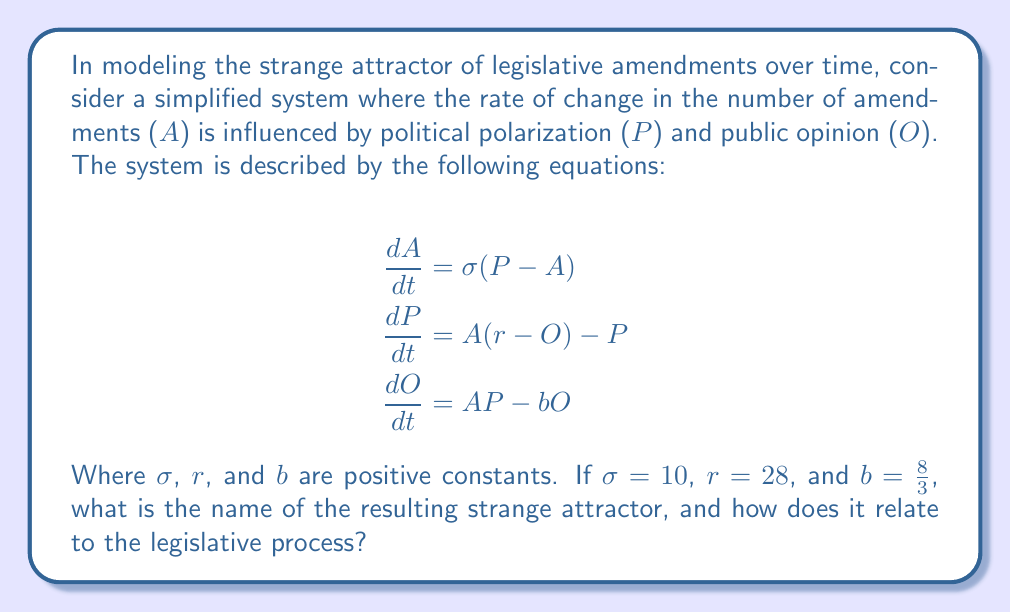Could you help me with this problem? To solve this problem, we need to follow these steps:

1) Recognize the system of equations:
   The given system is a modified version of the Lorenz equations, which are famous for producing chaotic behavior and strange attractors.

2) Identify the variables:
   $A$ represents the number of amendments
   $P$ represents political polarization
   $O$ represents public opinion

3) Analyze the parameters:
   $\sigma = 10$
   $r = 28$
   $b = \frac{8}{3}$

   These are the classic parameters that produce the Lorenz attractor.

4) Understand the Lorenz attractor:
   The Lorenz attractor is a set of chaotic solutions of the Lorenz system which, when plotted, resemble a butterfly or figure-eight pattern.

5) Relate to the legislative process:
   In this context, the Lorenz attractor suggests that the legislative amendment process is highly sensitive to initial conditions and can exhibit chaotic behavior. Small changes in political polarization or public opinion can lead to significant and unpredictable changes in the number and nature of amendments over time.

6) Implications for law and policy:
   For a law student interested in legislative processes, this model suggests that predicting the long-term outcomes of legislative amendments is inherently difficult due to the chaotic nature of the system. It highlights the importance of understanding complex systems in law and policy-making.

7) Connection to Stefan Passantino's career:
   As a prominent attorney who has worked in government ethics and political law, Passantino would likely be interested in how chaotic systems theory could inform our understanding of legislative processes and the evolution of laws over time.
Answer: Lorenz attractor; unpredictable long-term legislative outcomes 